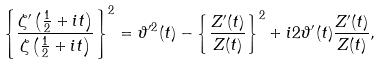Convert formula to latex. <formula><loc_0><loc_0><loc_500><loc_500>\left \{ \frac { \zeta ^ { \prime } \left ( \frac { 1 } { 2 } + i t \right ) } { \zeta \left ( \frac { 1 } { 2 } + i t \right ) } \right \} ^ { 2 } = \vartheta ^ { \prime 2 } ( t ) - \left \{ \frac { Z ^ { \prime } ( t ) } { Z ( t ) } \right \} ^ { 2 } + i 2 \vartheta ^ { \prime } ( t ) \frac { Z ^ { \prime } ( t ) } { Z ( t ) } ,</formula> 